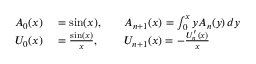<formula> <loc_0><loc_0><loc_500><loc_500>\begin{array} { r l r l } { A _ { 0 } ( x ) } & = \sin ( x ) , } & A _ { n + 1 } ( x ) = \int _ { 0 } ^ { x } y A _ { n } ( y ) \, d y } \\ { U _ { 0 } ( x ) } & = { \frac { \sin ( x ) } { x } } , } & U _ { n + 1 } ( x ) = - { \frac { U _ { n } ^ { \prime } ( x ) } { x } } } \end{array}</formula> 